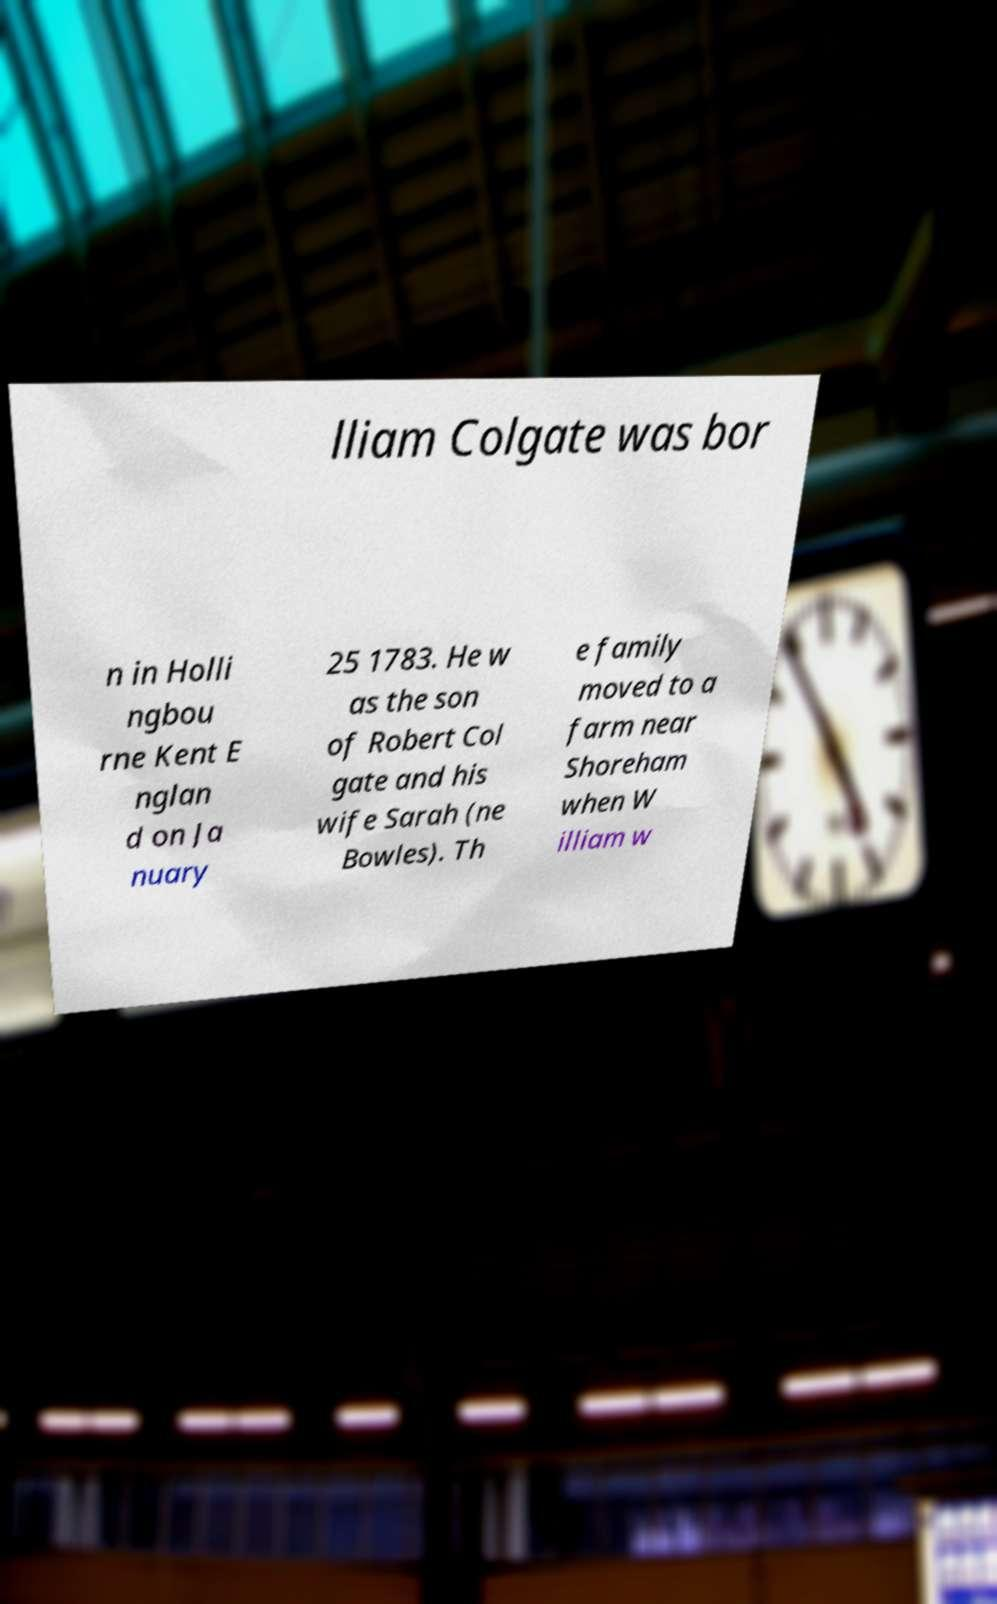There's text embedded in this image that I need extracted. Can you transcribe it verbatim? lliam Colgate was bor n in Holli ngbou rne Kent E nglan d on Ja nuary 25 1783. He w as the son of Robert Col gate and his wife Sarah (ne Bowles). Th e family moved to a farm near Shoreham when W illiam w 